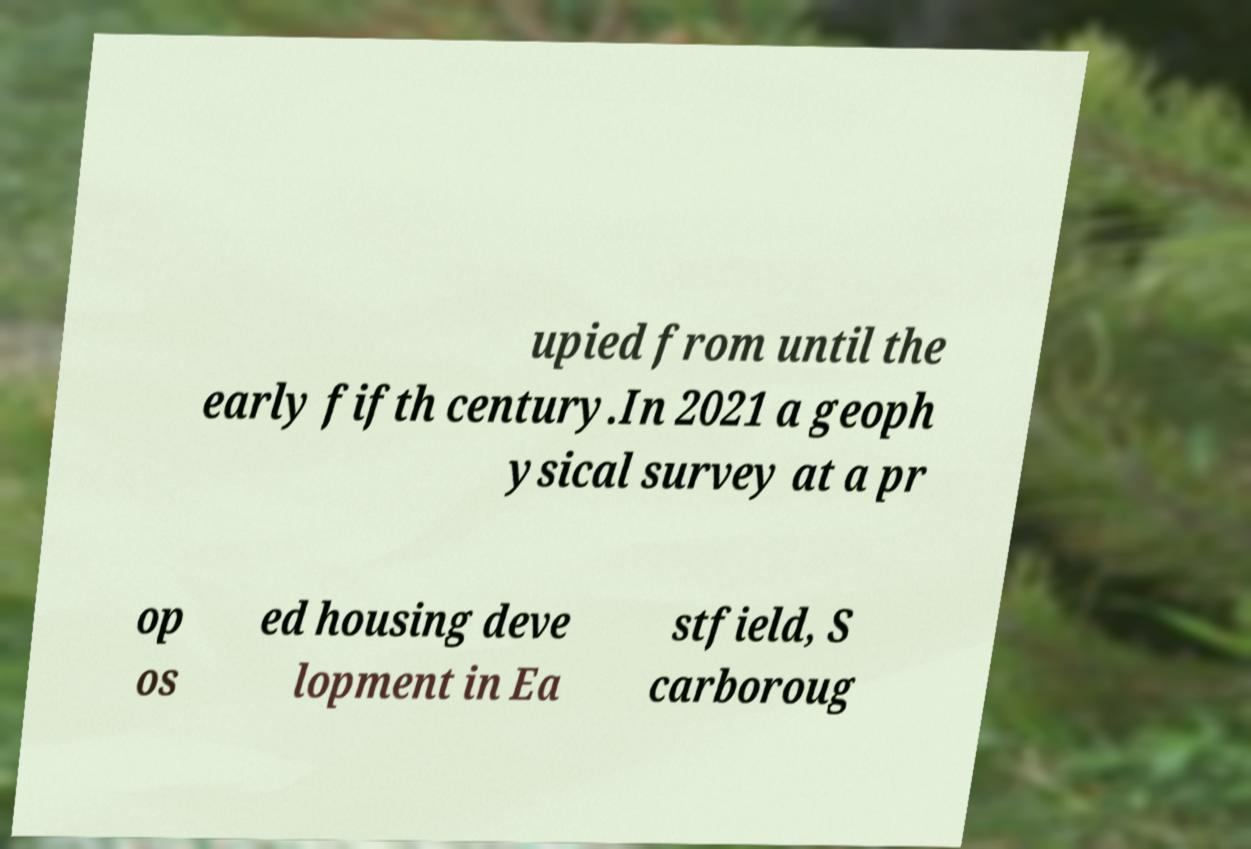Can you accurately transcribe the text from the provided image for me? upied from until the early fifth century.In 2021 a geoph ysical survey at a pr op os ed housing deve lopment in Ea stfield, S carboroug 